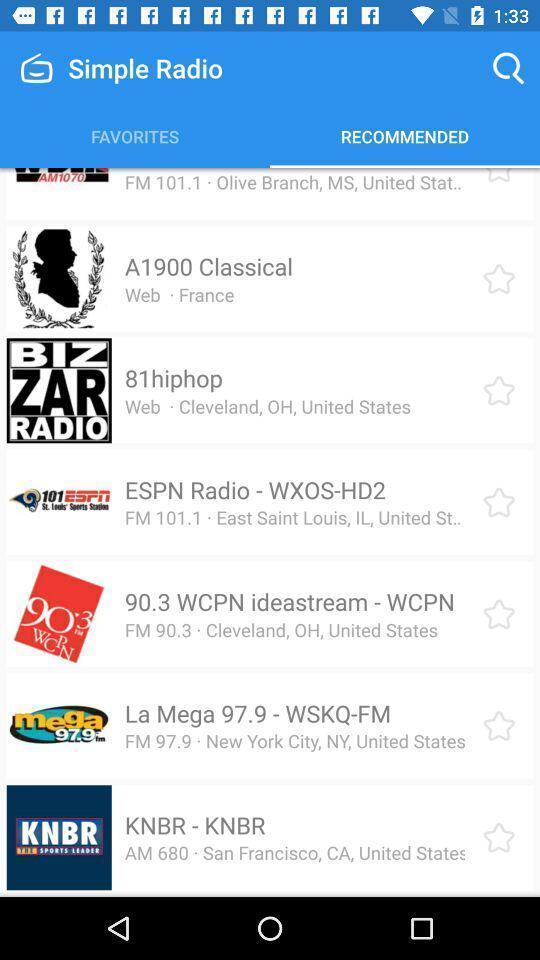Provide a description of this screenshot. Page showing the recommended channels in radio app. 